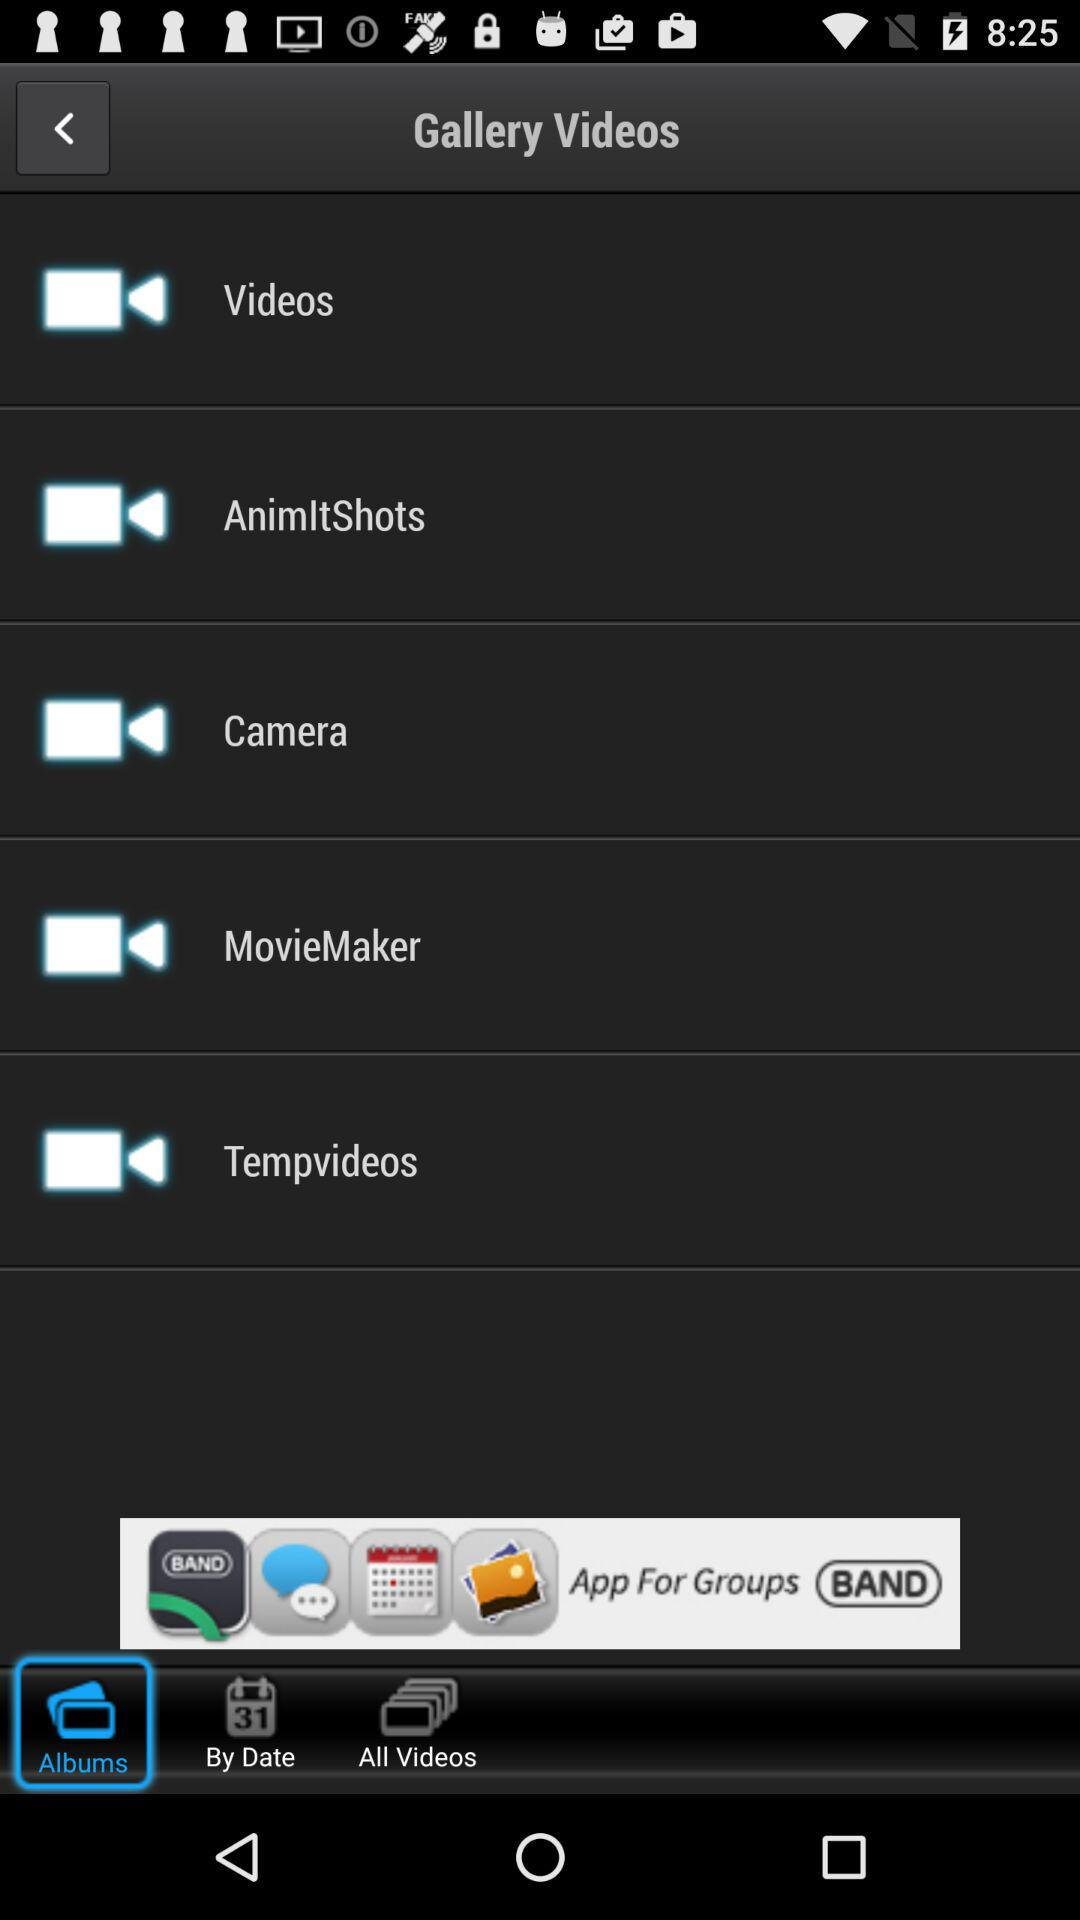Which tab has selected? The tab "Albums" has been selected. 